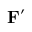Convert formula to latex. <formula><loc_0><loc_0><loc_500><loc_500>F ^ { \prime }</formula> 